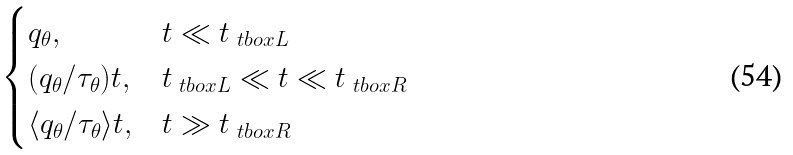<formula> <loc_0><loc_0><loc_500><loc_500>\begin{cases} q _ { \theta } , & t \ll t _ { \ t b o x { L } } \\ ( q _ { \theta } / \tau _ { \theta } ) t , & t _ { \ t b o x { L } } \ll t \ll t _ { \ t b o x { R } } \\ \langle q _ { \theta } / \tau _ { \theta } \rangle t , & t \gg t _ { \ t b o x { R } } \end{cases}</formula> 